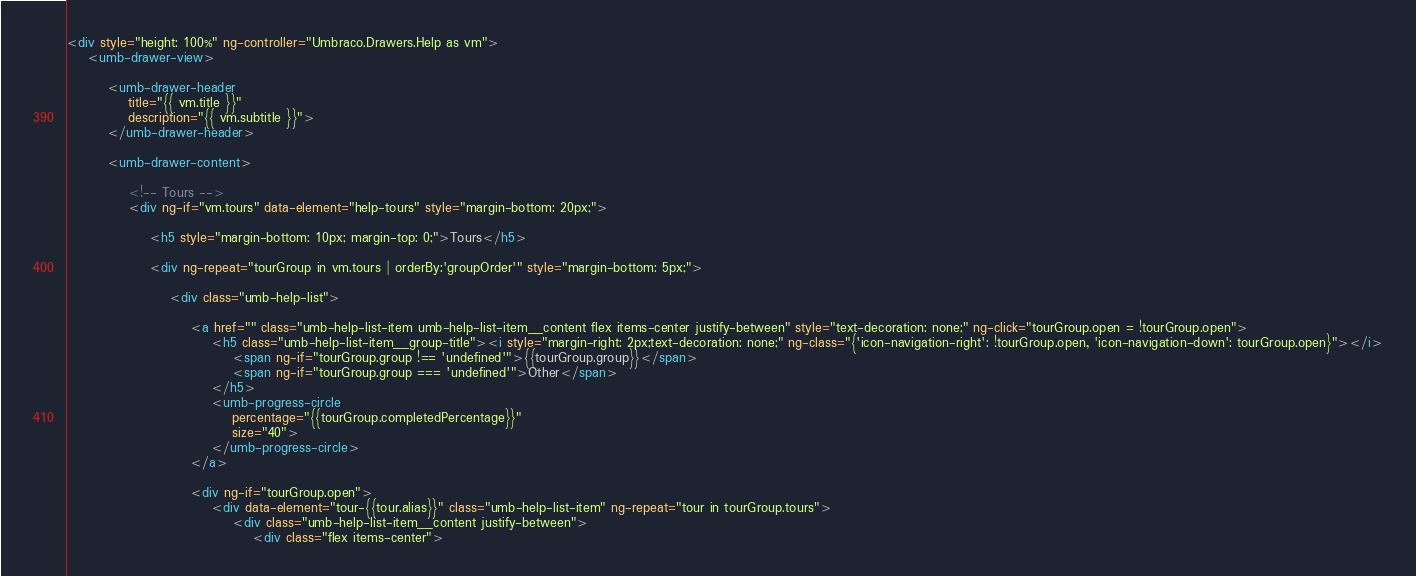<code> <loc_0><loc_0><loc_500><loc_500><_HTML_><div style="height: 100%" ng-controller="Umbraco.Drawers.Help as vm">
    <umb-drawer-view>

        <umb-drawer-header
            title="{{ vm.title }}"
            description="{{ vm.subtitle }}">
        </umb-drawer-header>

        <umb-drawer-content>

            <!-- Tours -->
            <div ng-if="vm.tours" data-element="help-tours" style="margin-bottom: 20px;">

                <h5 style="margin-bottom: 10px; margin-top: 0;">Tours</h5>
                
                <div ng-repeat="tourGroup in vm.tours | orderBy:'groupOrder'" style="margin-bottom: 5px;">

                    <div class="umb-help-list">

                        <a href="" class="umb-help-list-item umb-help-list-item__content flex items-center justify-between" style="text-decoration: none;" ng-click="tourGroup.open = !tourGroup.open">
                            <h5 class="umb-help-list-item__group-title"><i style="margin-right: 2px;text-decoration: none;" ng-class="{'icon-navigation-right': !tourGroup.open, 'icon-navigation-down': tourGroup.open}"></i>
                                <span ng-if="tourGroup.group !== 'undefined'">{{tourGroup.group}}</span>
                                <span ng-if="tourGroup.group === 'undefined'">Other</span>
                            </h5>
                            <umb-progress-circle
                                percentage="{{tourGroup.completedPercentage}}"
                                size="40">
                            </umb-progress-circle>
                        </a>

                        <div ng-if="tourGroup.open">
                            <div data-element="tour-{{tour.alias}}" class="umb-help-list-item" ng-repeat="tour in tourGroup.tours">
                                <div class="umb-help-list-item__content justify-between">
                                    <div class="flex items-center"></code> 